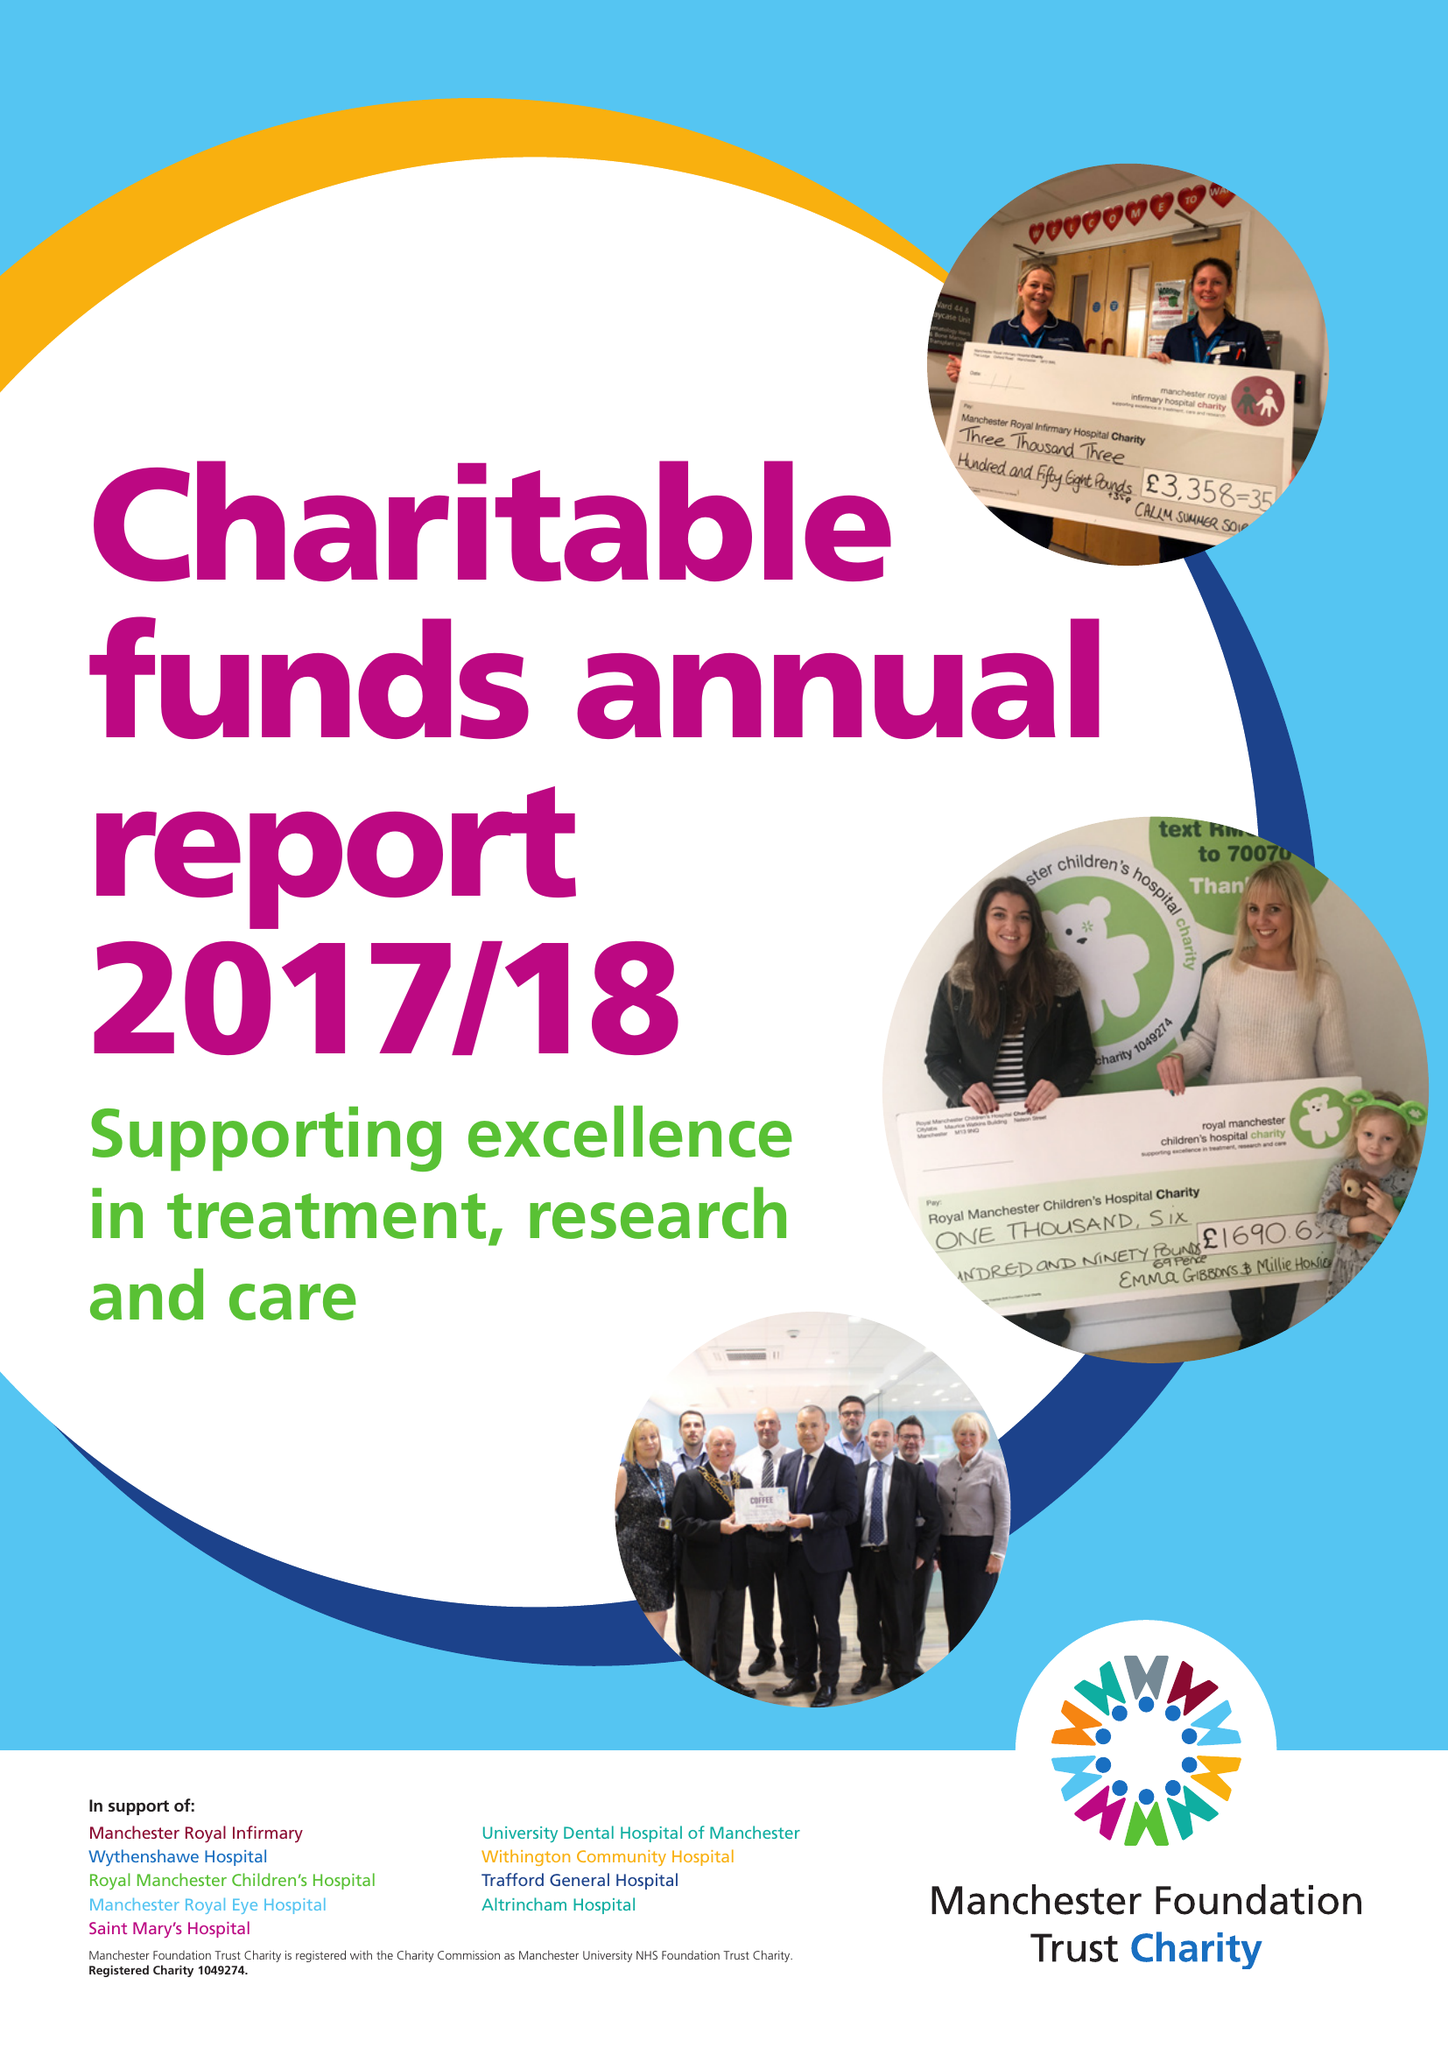What is the value for the charity_name?
Answer the question using a single word or phrase. Manchester University Nhs Foundation Trust Charity 